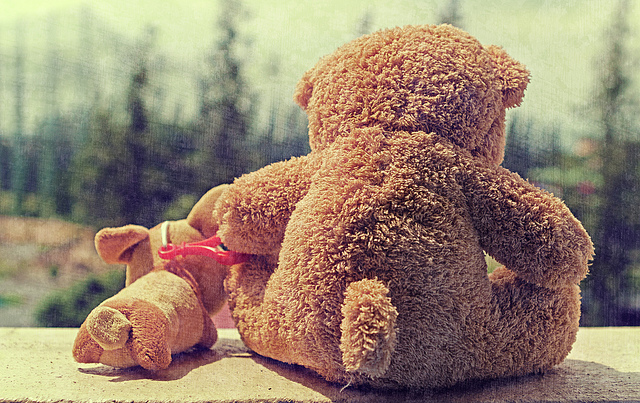What emotion does this scene of the teddy bears evoke? The scene with the teddy bears evokes a sense of solitude or introspection, perhaps implying a narrative of loss, waiting, or reflection. The way the larger teddy bear gazes out as if lost in thought, alongside the smaller one lying prostrate, suggests feelings of melancholy or contemplation. 